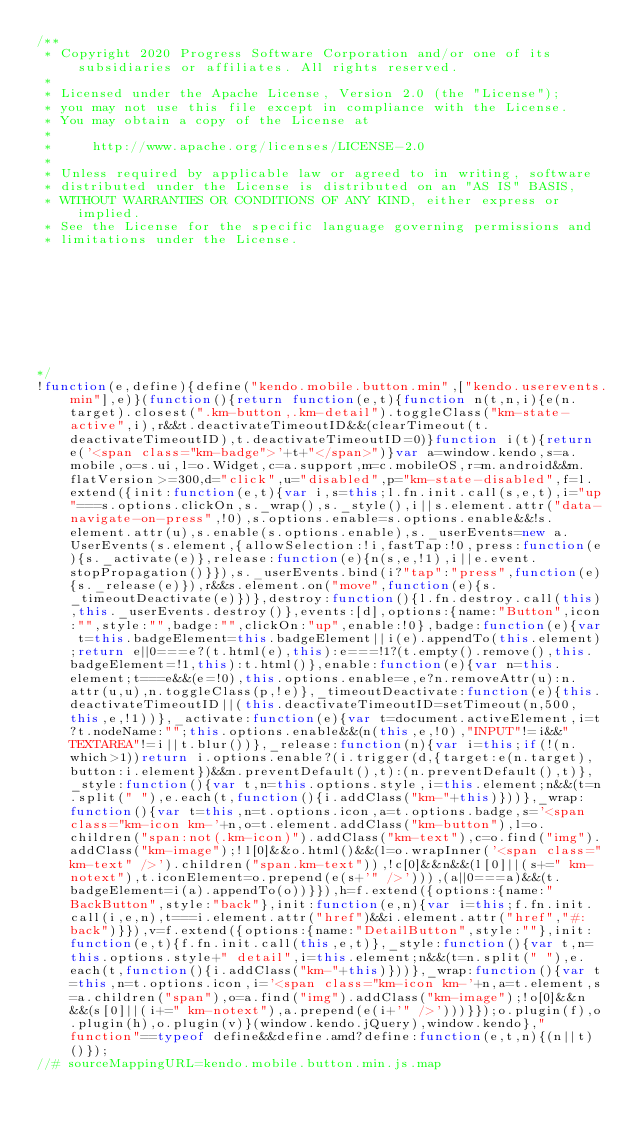Convert code to text. <code><loc_0><loc_0><loc_500><loc_500><_JavaScript_>/** 
 * Copyright 2020 Progress Software Corporation and/or one of its subsidiaries or affiliates. All rights reserved.                                                                                      
 *                                                                                                                                                                                                      
 * Licensed under the Apache License, Version 2.0 (the "License");                                                                                                                                      
 * you may not use this file except in compliance with the License.                                                                                                                                     
 * You may obtain a copy of the License at                                                                                                                                                              
 *                                                                                                                                                                                                      
 *     http://www.apache.org/licenses/LICENSE-2.0                                                                                                                                                       
 *                                                                                                                                                                                                      
 * Unless required by applicable law or agreed to in writing, software                                                                                                                                  
 * distributed under the License is distributed on an "AS IS" BASIS,                                                                                                                                    
 * WITHOUT WARRANTIES OR CONDITIONS OF ANY KIND, either express or implied.                                                                                                                             
 * See the License for the specific language governing permissions and                                                                                                                                  
 * limitations under the License.                                                                                                                                                                       
                                                                                                                                                                                                       
                                                                                                                                                                                                       
                                                                                                                                                                                                       
                                                                                                                                                                                                       
                                                                                                                                                                                                       
                                                                                                                                                                                                       
                                                                                                                                                                                                       
                                                                                                                                                                                                       

*/
!function(e,define){define("kendo.mobile.button.min",["kendo.userevents.min"],e)}(function(){return function(e,t){function n(t,n,i){e(n.target).closest(".km-button,.km-detail").toggleClass("km-state-active",i),r&&t.deactivateTimeoutID&&(clearTimeout(t.deactivateTimeoutID),t.deactivateTimeoutID=0)}function i(t){return e('<span class="km-badge">'+t+"</span>")}var a=window.kendo,s=a.mobile,o=s.ui,l=o.Widget,c=a.support,m=c.mobileOS,r=m.android&&m.flatVersion>=300,d="click",u="disabled",p="km-state-disabled",f=l.extend({init:function(e,t){var i,s=this;l.fn.init.call(s,e,t),i="up"===s.options.clickOn,s._wrap(),s._style(),i||s.element.attr("data-navigate-on-press",!0),s.options.enable=s.options.enable&&!s.element.attr(u),s.enable(s.options.enable),s._userEvents=new a.UserEvents(s.element,{allowSelection:!i,fastTap:!0,press:function(e){s._activate(e)},release:function(e){n(s,e,!1),i||e.event.stopPropagation()}}),s._userEvents.bind(i?"tap":"press",function(e){s._release(e)}),r&&s.element.on("move",function(e){s._timeoutDeactivate(e)})},destroy:function(){l.fn.destroy.call(this),this._userEvents.destroy()},events:[d],options:{name:"Button",icon:"",style:"",badge:"",clickOn:"up",enable:!0},badge:function(e){var t=this.badgeElement=this.badgeElement||i(e).appendTo(this.element);return e||0===e?(t.html(e),this):e===!1?(t.empty().remove(),this.badgeElement=!1,this):t.html()},enable:function(e){var n=this.element;t===e&&(e=!0),this.options.enable=e,e?n.removeAttr(u):n.attr(u,u),n.toggleClass(p,!e)},_timeoutDeactivate:function(e){this.deactivateTimeoutID||(this.deactivateTimeoutID=setTimeout(n,500,this,e,!1))},_activate:function(e){var t=document.activeElement,i=t?t.nodeName:"";this.options.enable&&(n(this,e,!0),"INPUT"!=i&&"TEXTAREA"!=i||t.blur())},_release:function(n){var i=this;if(!(n.which>1))return i.options.enable?(i.trigger(d,{target:e(n.target),button:i.element})&&n.preventDefault(),t):(n.preventDefault(),t)},_style:function(){var t,n=this.options.style,i=this.element;n&&(t=n.split(" "),e.each(t,function(){i.addClass("km-"+this)}))},_wrap:function(){var t=this,n=t.options.icon,a=t.options.badge,s='<span class="km-icon km-'+n,o=t.element.addClass("km-button"),l=o.children("span:not(.km-icon)").addClass("km-text"),c=o.find("img").addClass("km-image");!l[0]&&o.html()&&(l=o.wrapInner('<span class="km-text" />').children("span.km-text")),!c[0]&&n&&(l[0]||(s+=" km-notext"),t.iconElement=o.prepend(e(s+'" />'))),(a||0===a)&&(t.badgeElement=i(a).appendTo(o))}}),h=f.extend({options:{name:"BackButton",style:"back"},init:function(e,n){var i=this;f.fn.init.call(i,e,n),t===i.element.attr("href")&&i.element.attr("href","#:back")}}),v=f.extend({options:{name:"DetailButton",style:""},init:function(e,t){f.fn.init.call(this,e,t)},_style:function(){var t,n=this.options.style+" detail",i=this.element;n&&(t=n.split(" "),e.each(t,function(){i.addClass("km-"+this)}))},_wrap:function(){var t=this,n=t.options.icon,i='<span class="km-icon km-'+n,a=t.element,s=a.children("span"),o=a.find("img").addClass("km-image");!o[0]&&n&&(s[0]||(i+=" km-notext"),a.prepend(e(i+'" />')))}});o.plugin(f),o.plugin(h),o.plugin(v)}(window.kendo.jQuery),window.kendo},"function"==typeof define&&define.amd?define:function(e,t,n){(n||t)()});
//# sourceMappingURL=kendo.mobile.button.min.js.map
</code> 